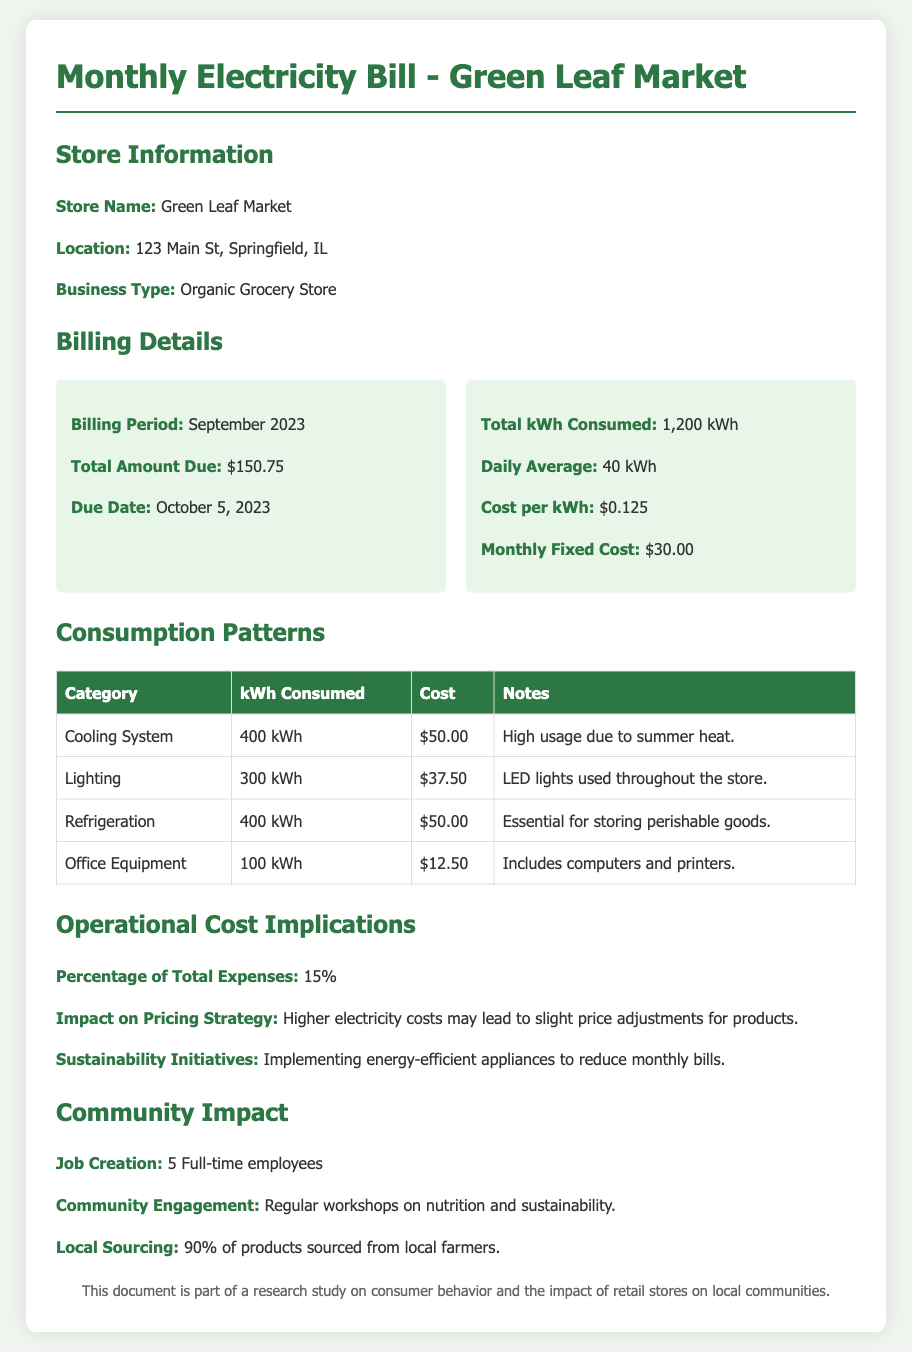what is the store name? The store name is located in the store information section of the document.
Answer: Green Leaf Market what is the total amount due? The total amount due is highlighted in the billing details section of the document.
Answer: $150.75 what was the total kWh consumed? The total kWh consumed is stated in the billing details section of the document.
Answer: 1,200 kWh what is the cost per kWh? The cost per kWh is mentioned in the billing details section of the document.
Answer: $0.125 how much energy did the cooling system consume? The kWh consumed by the cooling system can be found in the consumption patterns table.
Answer: 400 kWh what percentage of total expenses does the electricity bill represent? The percentage is specified in the operational cost implications section of the document.
Answer: 15% how many full-time employees does the store have? The number of full-time employees is provided in the community impact section of the document.
Answer: 5 what is the store's approach to sustainability? The store's sustainability initiatives are detailed in the operational cost implications section.
Answer: Implementing energy-efficient appliances what is the monthly fixed cost? The monthly fixed cost is listed in the billing details.
Answer: $30.00 